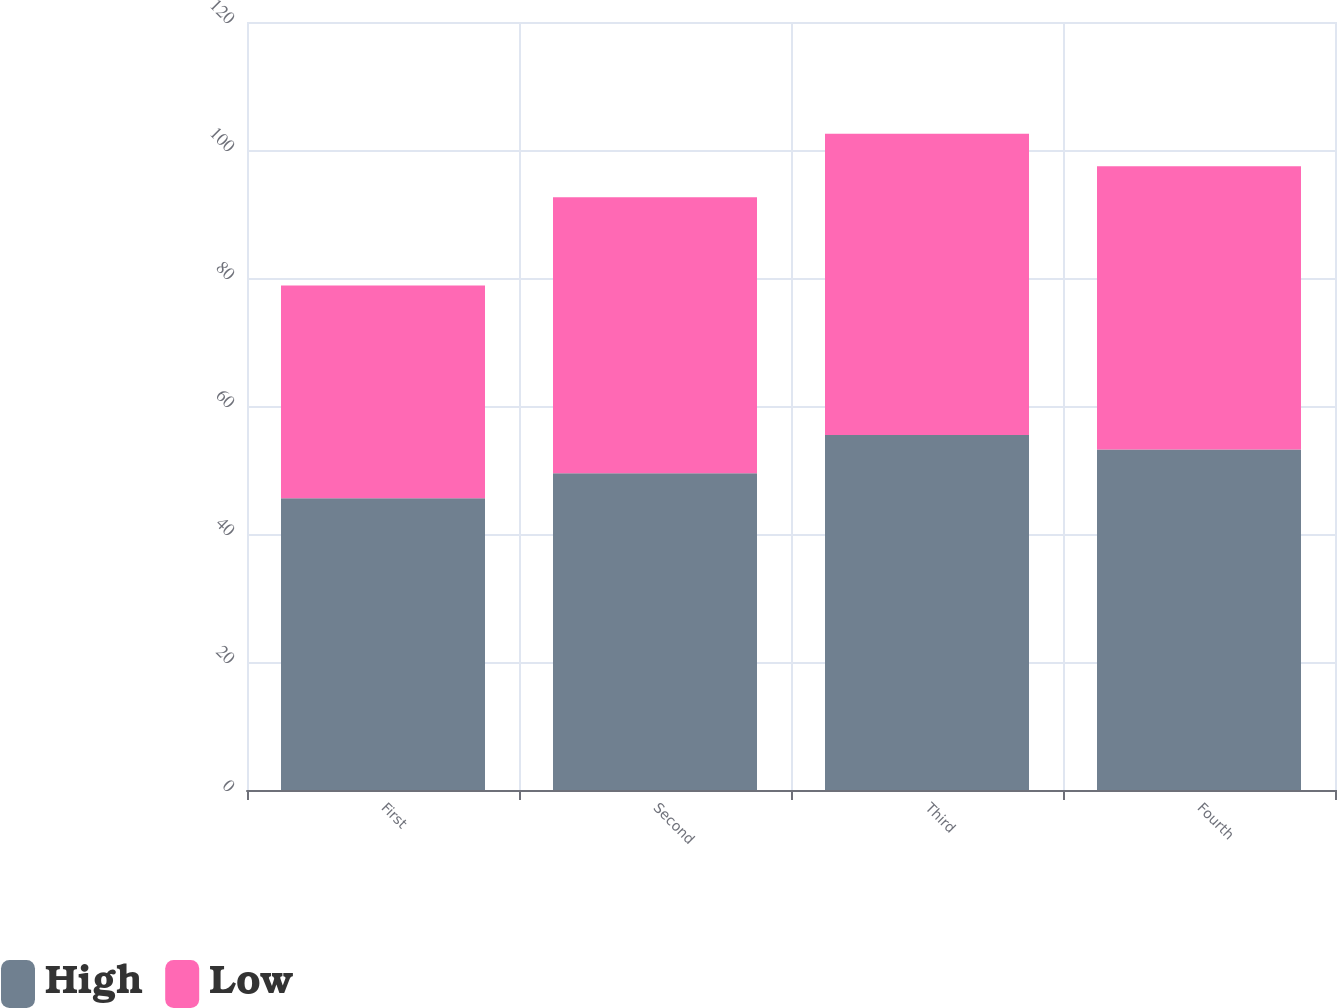<chart> <loc_0><loc_0><loc_500><loc_500><stacked_bar_chart><ecel><fcel>First<fcel>Second<fcel>Third<fcel>Fourth<nl><fcel>High<fcel>45.57<fcel>49.49<fcel>55.45<fcel>53.22<nl><fcel>Low<fcel>33.26<fcel>43.11<fcel>47.07<fcel>44.24<nl></chart> 